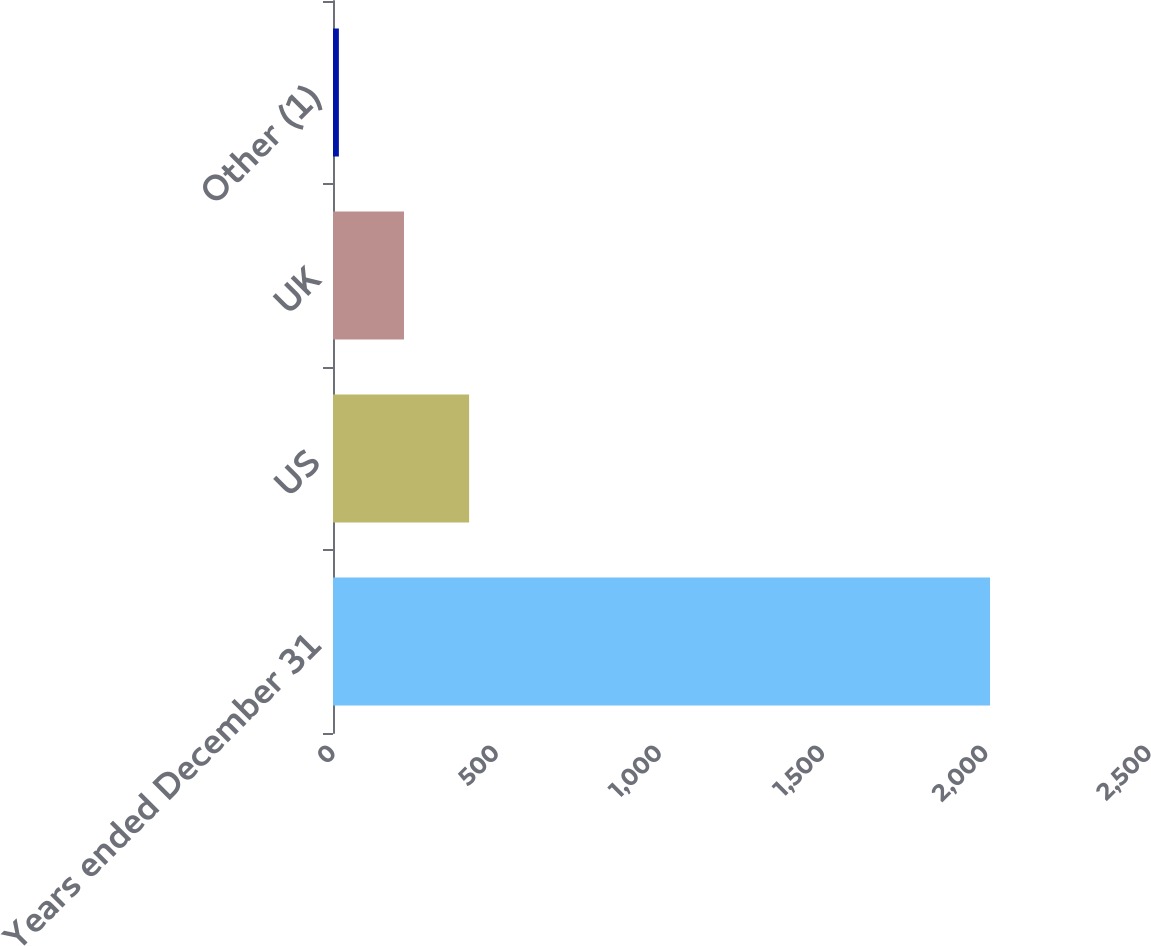Convert chart. <chart><loc_0><loc_0><loc_500><loc_500><bar_chart><fcel>Years ended December 31<fcel>US<fcel>UK<fcel>Other (1)<nl><fcel>2013<fcel>417<fcel>217.5<fcel>18<nl></chart> 